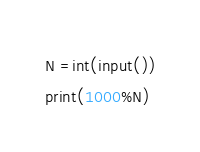<code> <loc_0><loc_0><loc_500><loc_500><_Python_>N =int(input())
print(1000%N)</code> 